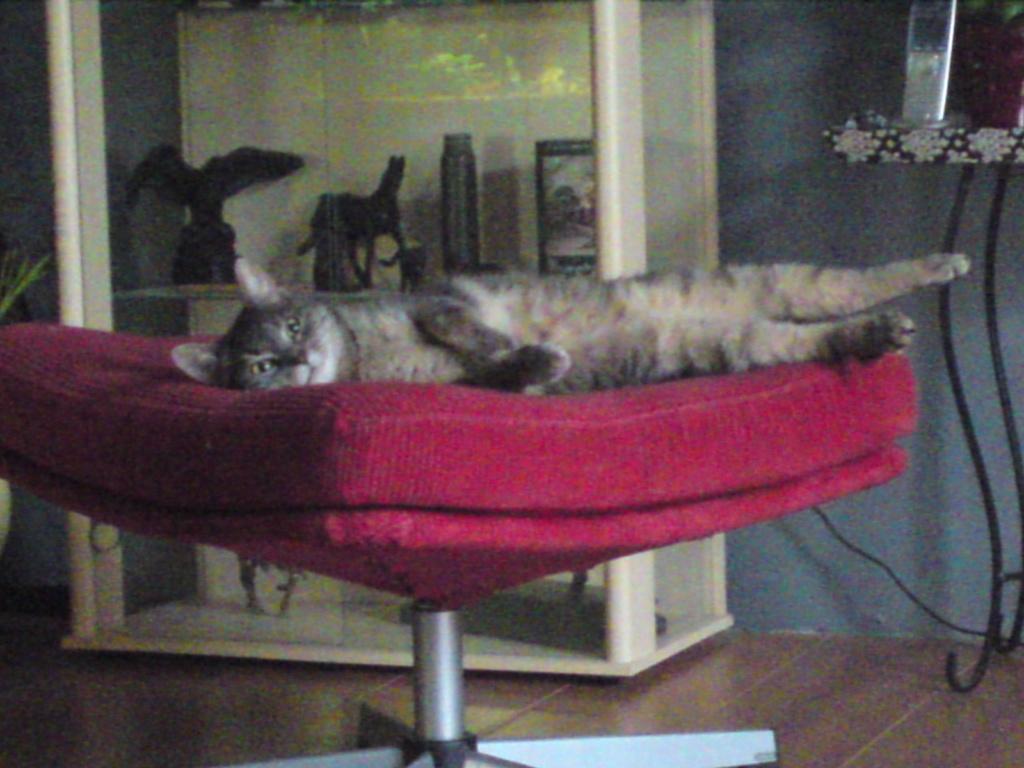Describe this image in one or two sentences. In this image there is a cat sleeping on the chair, behind the cat the is a cupboard with some objects, beside that there is a mobile phone on the table. 